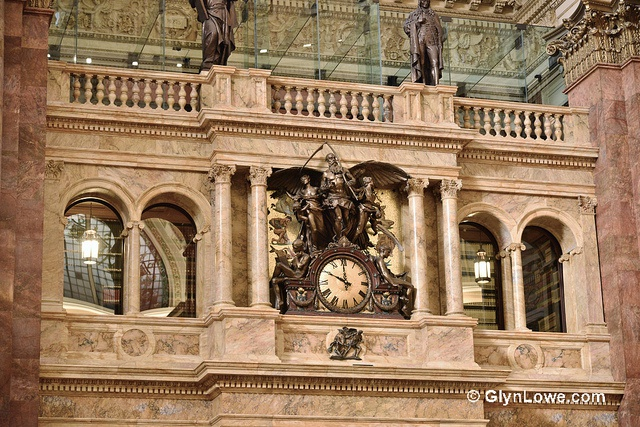Describe the objects in this image and their specific colors. I can see a clock in brown, tan, maroon, and black tones in this image. 